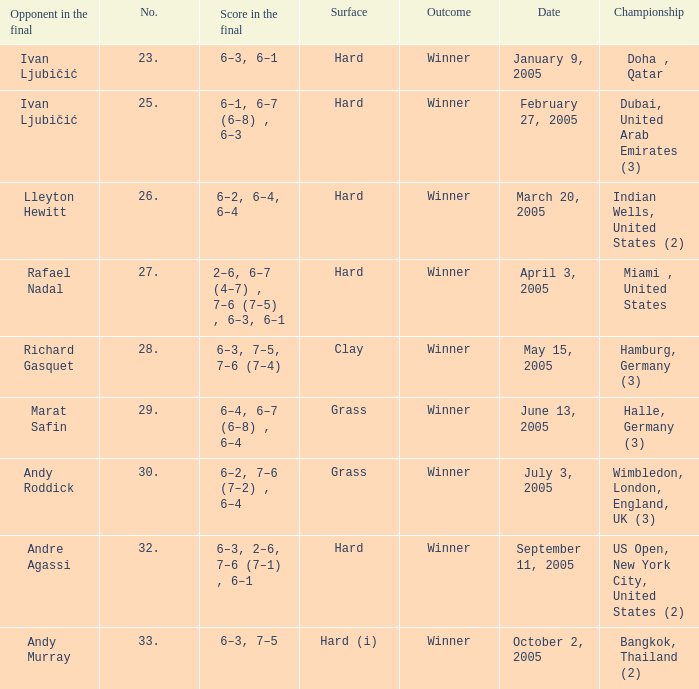Andy Roddick is the opponent in the final on what surface? Grass. 